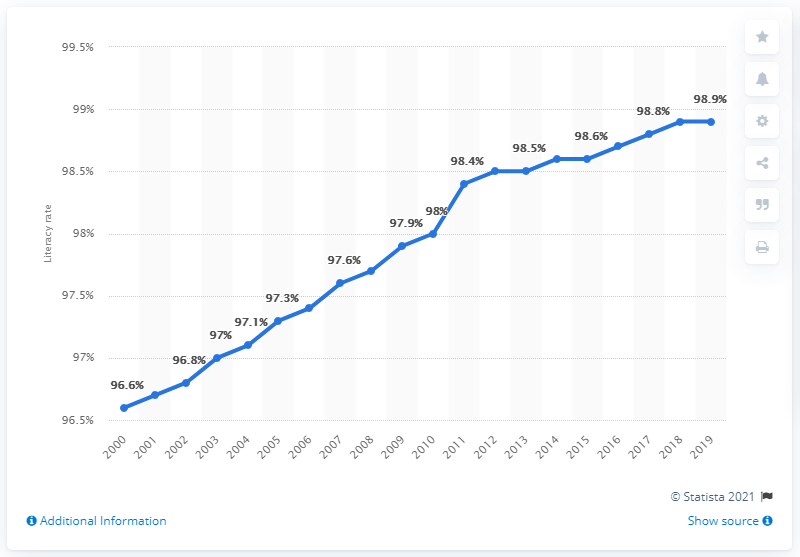Indicate a few pertinent items in this graphic. According to data from 2019, the literacy rate for males in Singapore was 98.9%. 